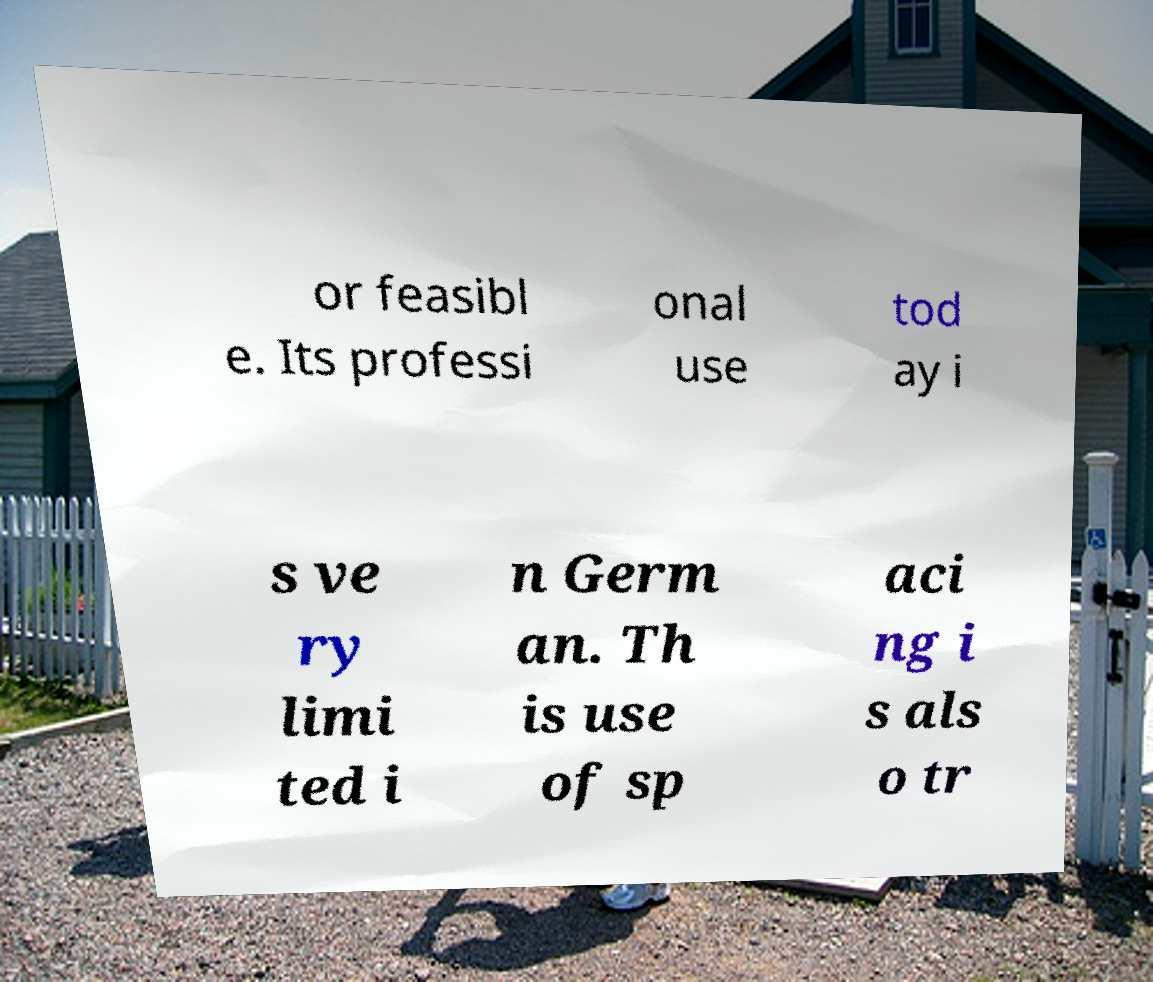There's text embedded in this image that I need extracted. Can you transcribe it verbatim? or feasibl e. Its professi onal use tod ay i s ve ry limi ted i n Germ an. Th is use of sp aci ng i s als o tr 